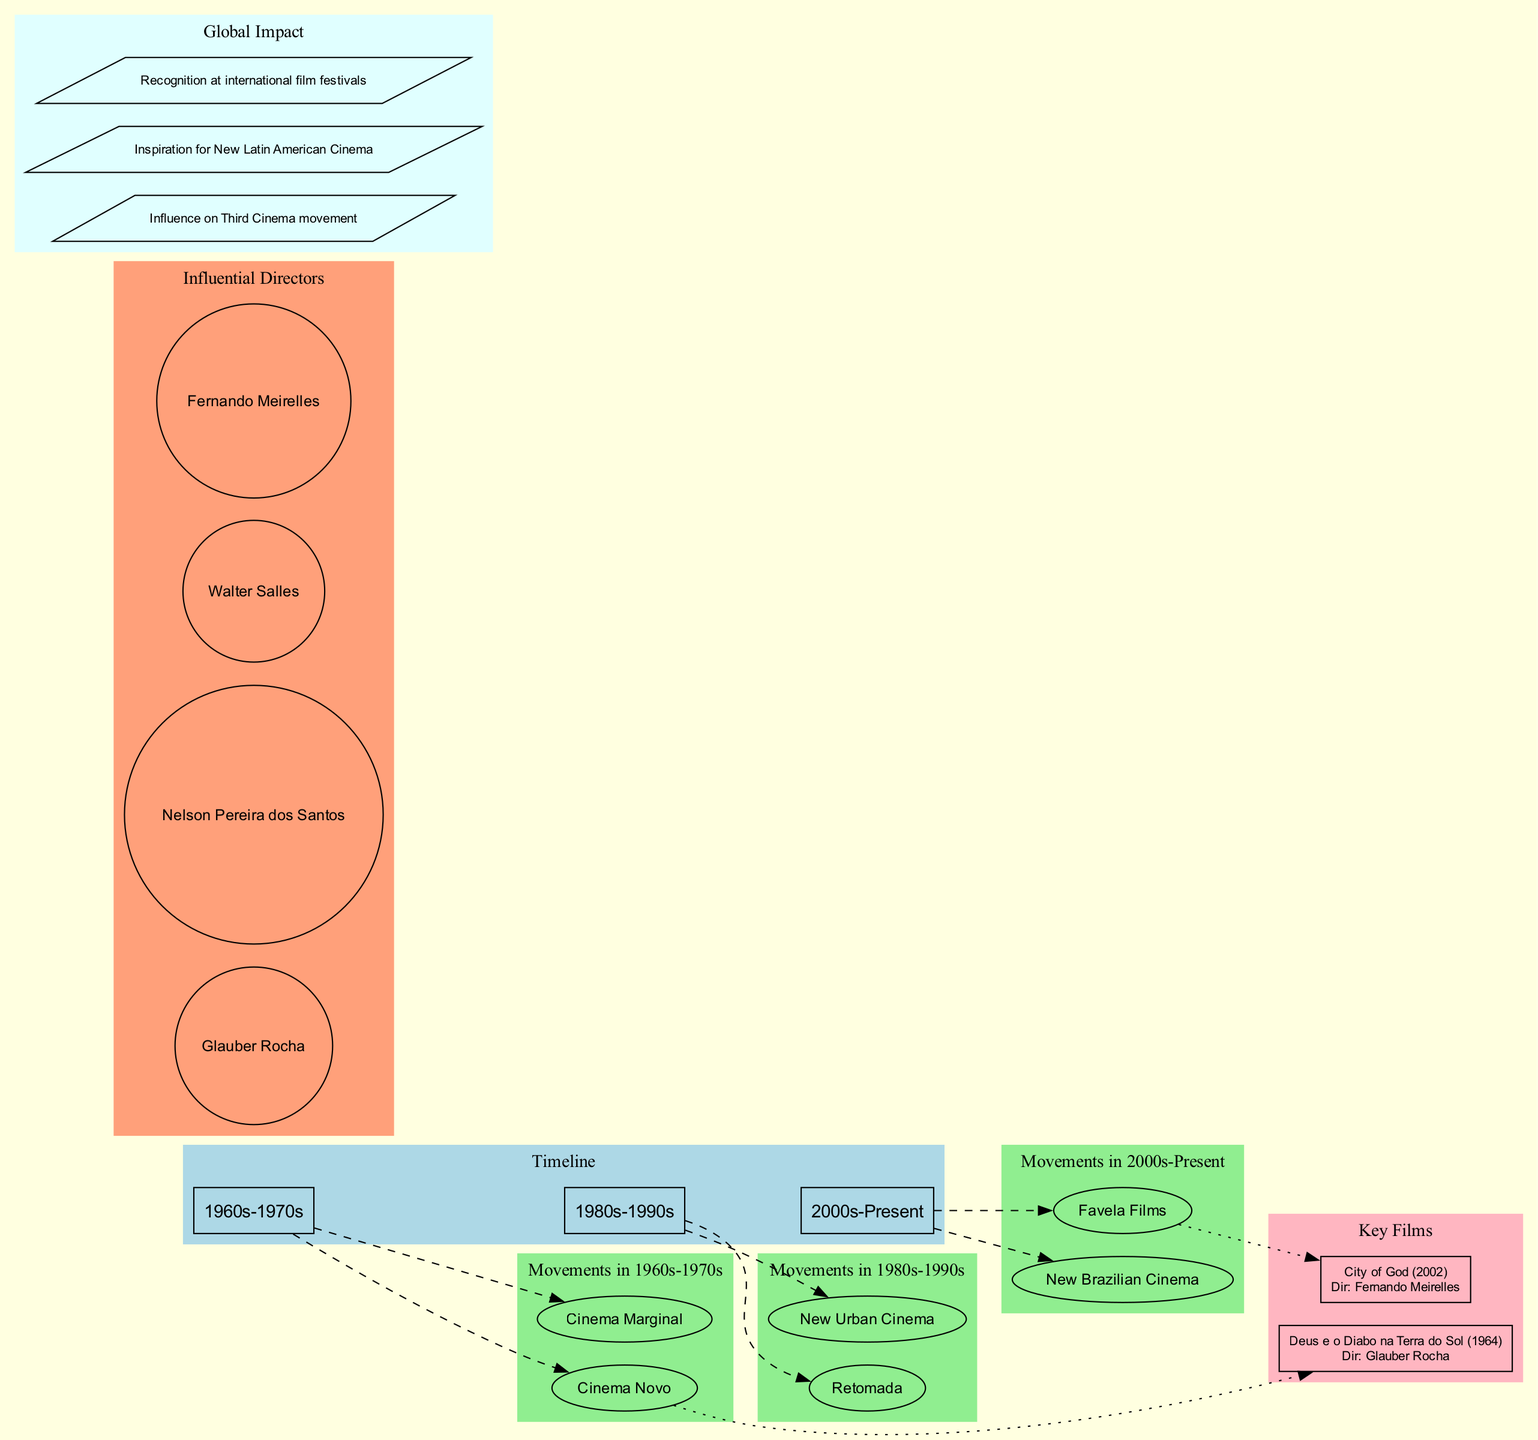What are the main movements in the 1980s-1990s era? The diagram specifically indicates that the movements in the 1980s-1990s are "Retomada" and "New Urban Cinema." This information is found within the box labeled for that era.
Answer: Retomada, New Urban Cinema How many key films are listed in the diagram? The diagram provides information about two key films, which are indicated in the 'Key Films' section. Each film is listed separately, and counting them yields a total of two.
Answer: 2 What is the movement associated with the film "City of God"? In the diagram, "City of God" is linked to the "Favela Films" movement. This relationship is depicted through a dotted edge connecting the film and its corresponding movement.
Answer: Favela Films Who directed the film "Deus e o Diabo na Terra do Sol"? The diagram clearly states that "Deus e o Diabo na Terra do Sol" was directed by Glauber Rocha. This information is shown within the node representing the film, including both its title and director.
Answer: Glauber Rocha Which movement is linked to Glauber Rocha? Glauber Rocha is associated with the movement called "Cinema Novo," as illustrated in the diagram where his name appears in the section for influential directors, connected to the movement that he pioneered.
Answer: Cinema Novo What impact of Brazilian cinema is mentioned in the diagram? The diagram highlights several impacts, but one significant impact mentioned is "Influence on Third Cinema movement." This is one of the points listed in the 'Global Impact' section, showcasing Brazilian cinema's influence.
Answer: Influence on Third Cinema movement Which era features both Cinema Novo and Cinema Marginal? The diagram indicates that both movements, "Cinema Novo" and "Cinema Marginal," are featured in the 1960s-1970s era. This is visually represented within the specified box for that era.
Answer: 1960s-1970s List one influential director mentioned in the diagram. The diagram outlines several influential directors in Brazilian cinema. One of them is Glauber Rocha, which can be found in the section dedicated to influential directors.
Answer: Glauber Rocha How many different eras are represented in the timeline? The diagram represents three distinct eras regarding Brazilian cinema movements: 1960s-1970s, 1980s-1990s, and 2000s-Present. Counting the items in the timeline shows a total of three eras.
Answer: 3 